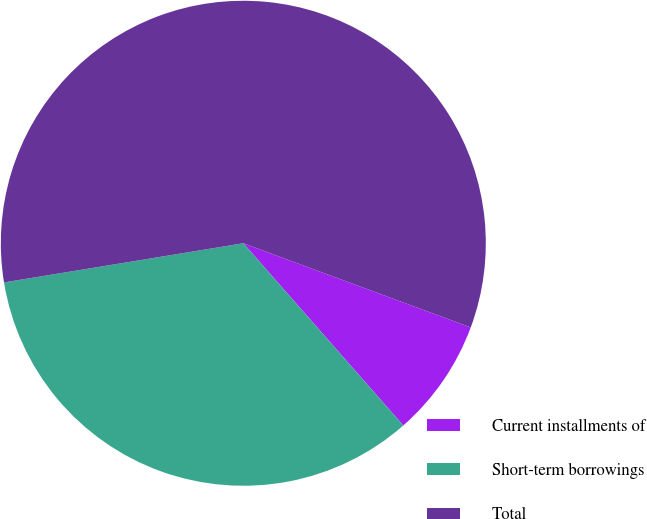<chart> <loc_0><loc_0><loc_500><loc_500><pie_chart><fcel>Current installments of<fcel>Short-term borrowings<fcel>Total<nl><fcel>7.89%<fcel>33.88%<fcel>58.22%<nl></chart> 